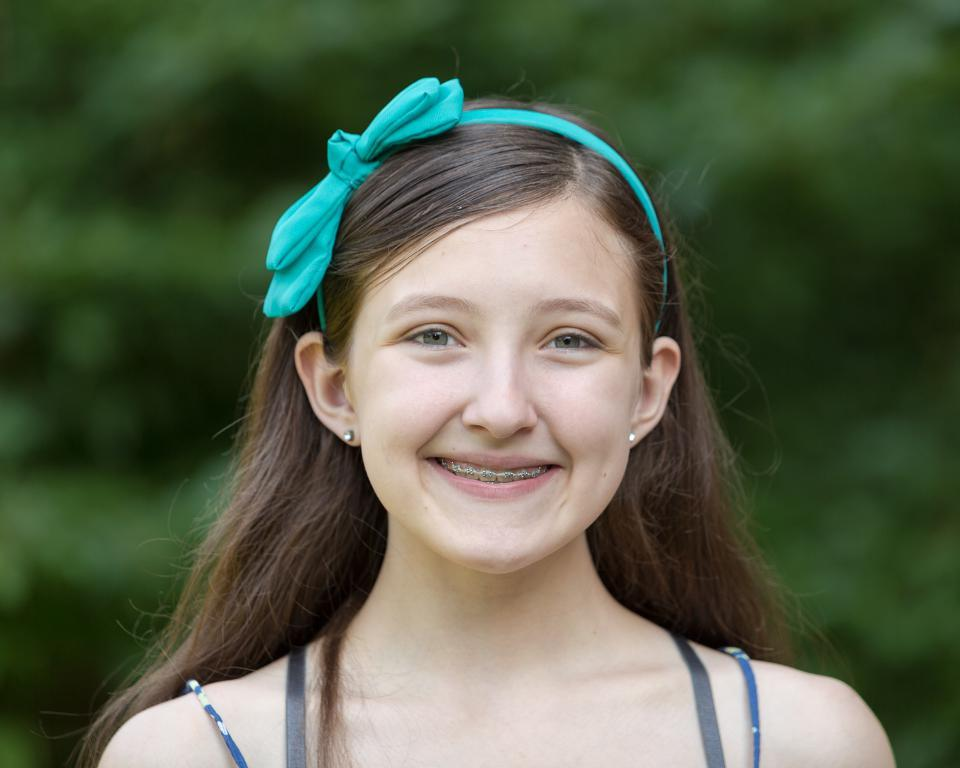What is the main subject of the image? There is a person in the image. How is the person's facial expression? The person has a smiling face. Can you describe the background of the image? The background of the image is blurry. What type of pleasure can be seen enjoying the cat in the image? There is no cat present in the image, and therefore no pleasure or interaction with a cat can be observed. What is the level of friction between the person and the background in the image? The level of friction between the person and the background cannot be determined from the image, as it is a photograph and not a physical interaction. 